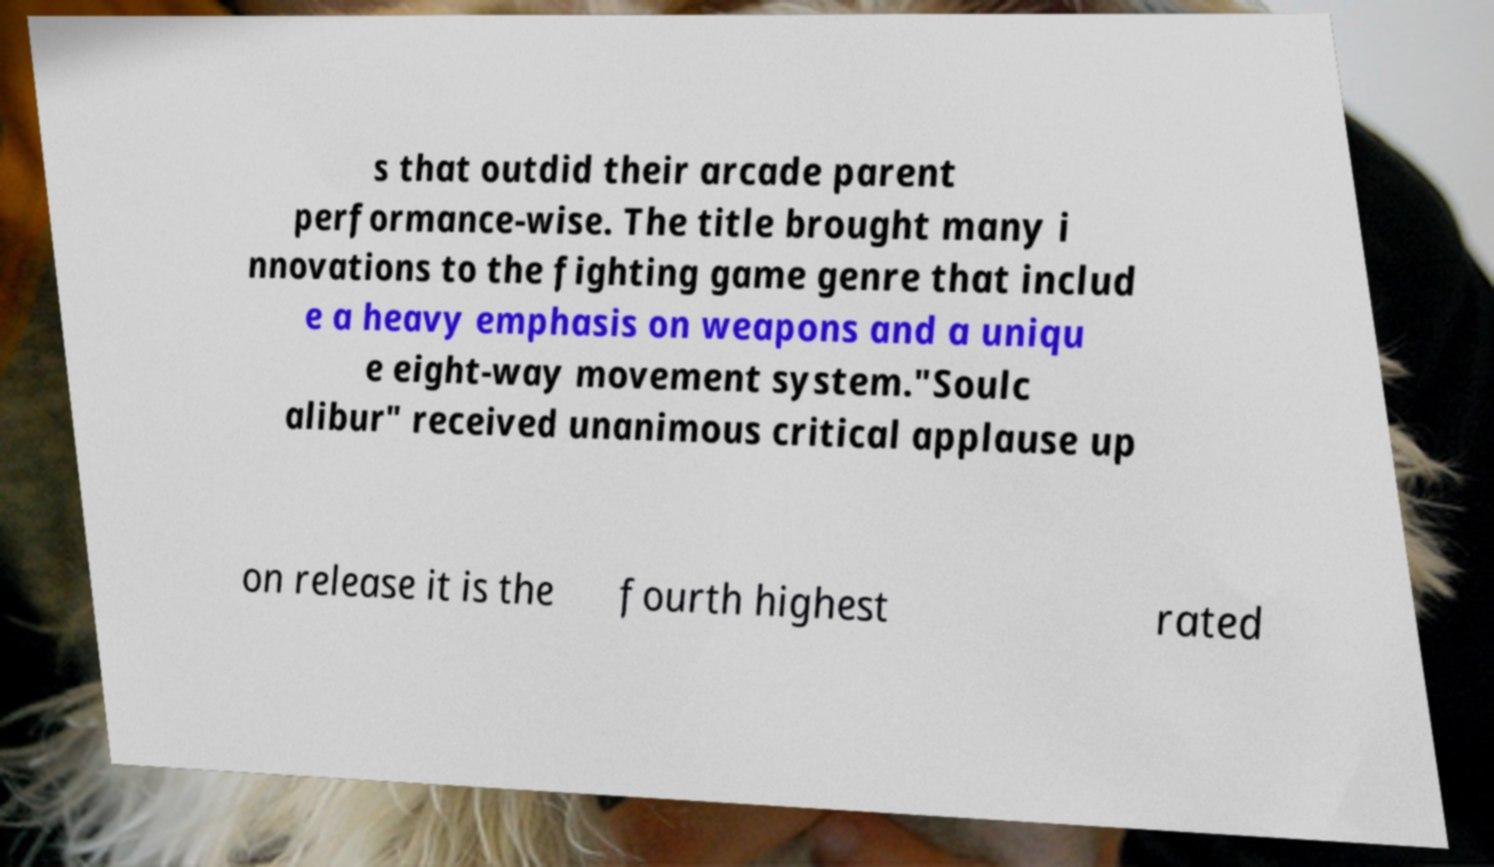Could you extract and type out the text from this image? s that outdid their arcade parent performance-wise. The title brought many i nnovations to the fighting game genre that includ e a heavy emphasis on weapons and a uniqu e eight-way movement system."Soulc alibur" received unanimous critical applause up on release it is the fourth highest rated 